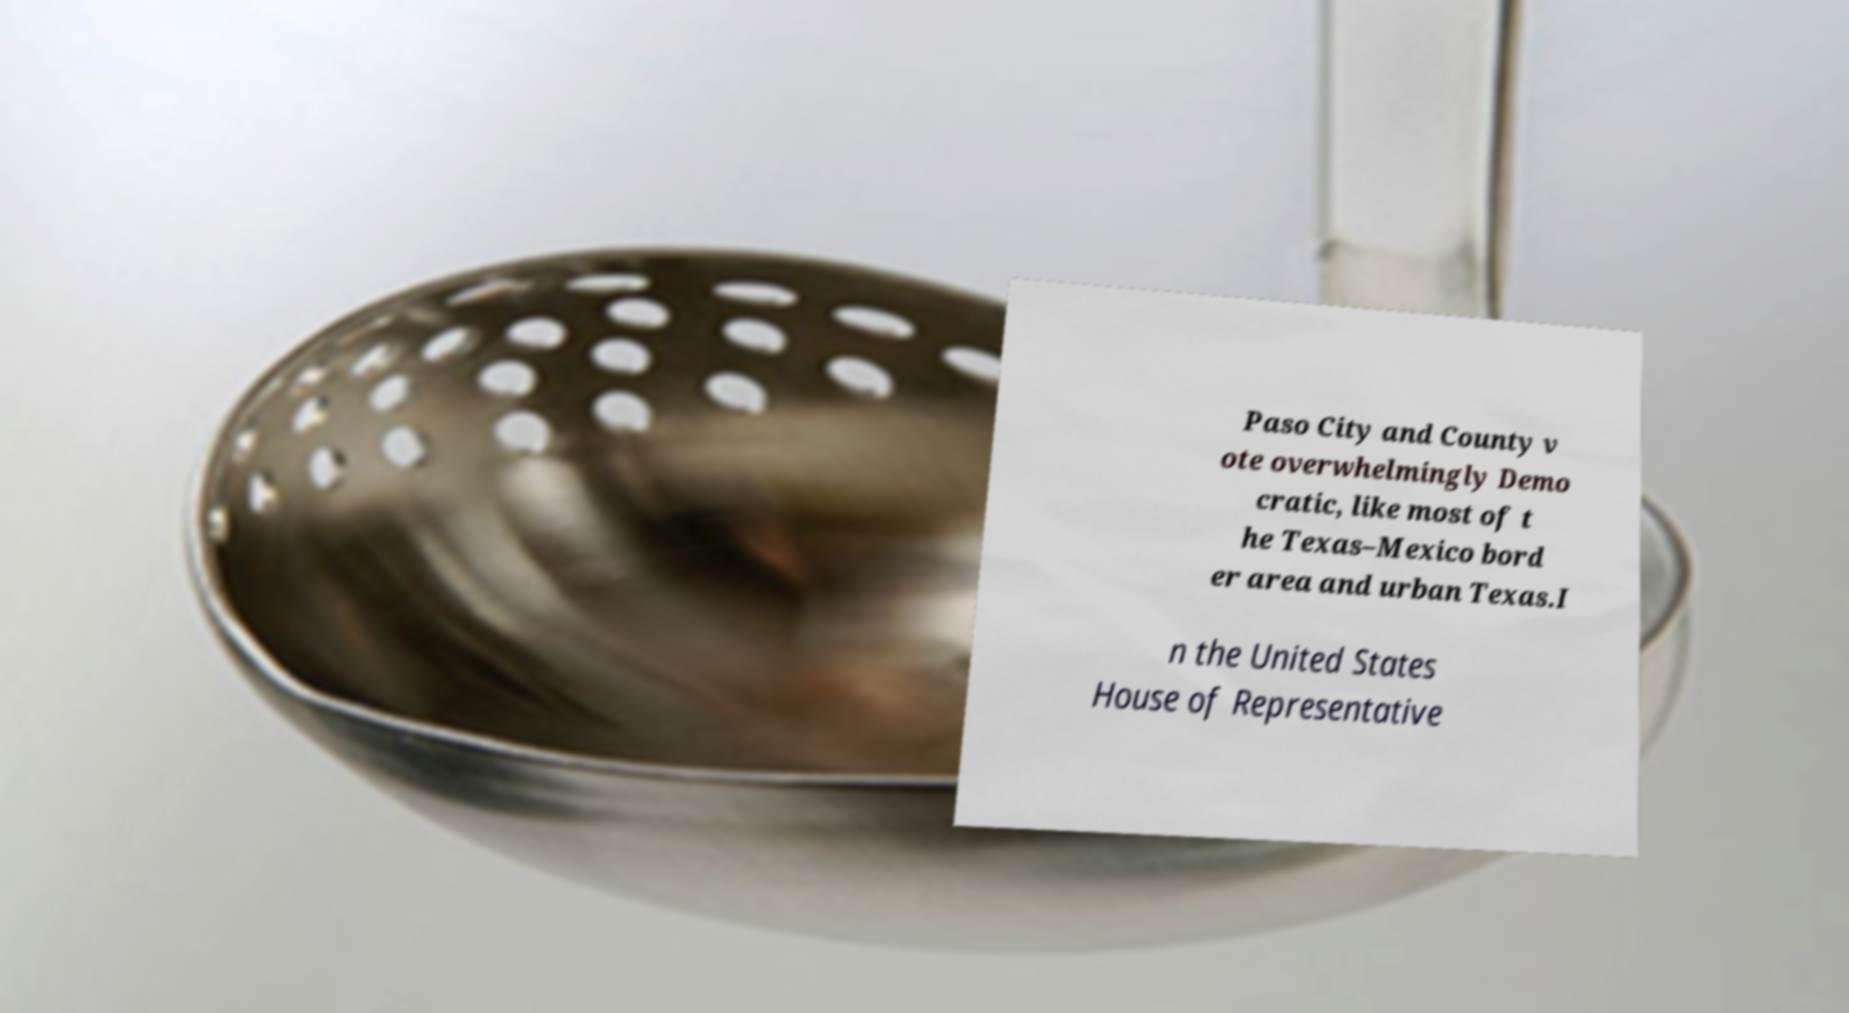Could you extract and type out the text from this image? Paso City and County v ote overwhelmingly Demo cratic, like most of t he Texas–Mexico bord er area and urban Texas.I n the United States House of Representative 